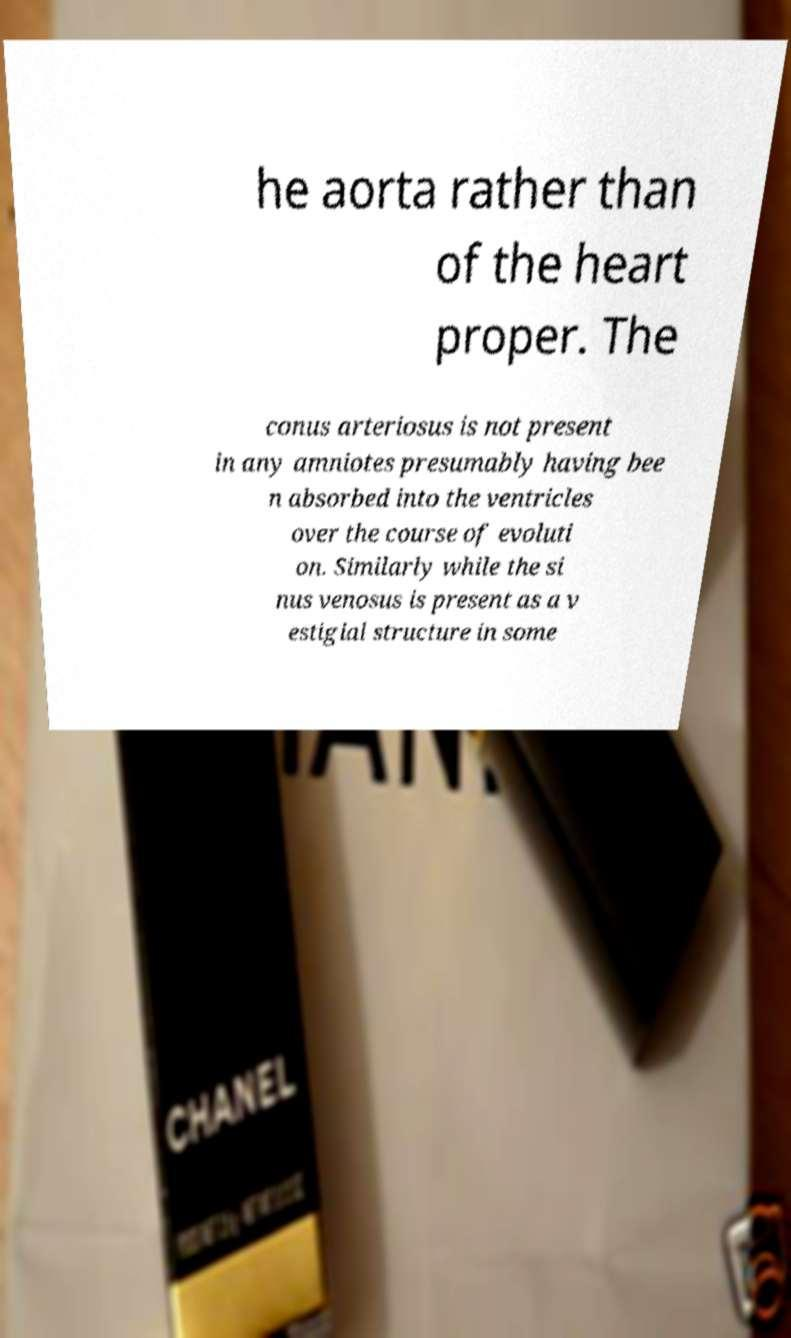There's text embedded in this image that I need extracted. Can you transcribe it verbatim? he aorta rather than of the heart proper. The conus arteriosus is not present in any amniotes presumably having bee n absorbed into the ventricles over the course of evoluti on. Similarly while the si nus venosus is present as a v estigial structure in some 